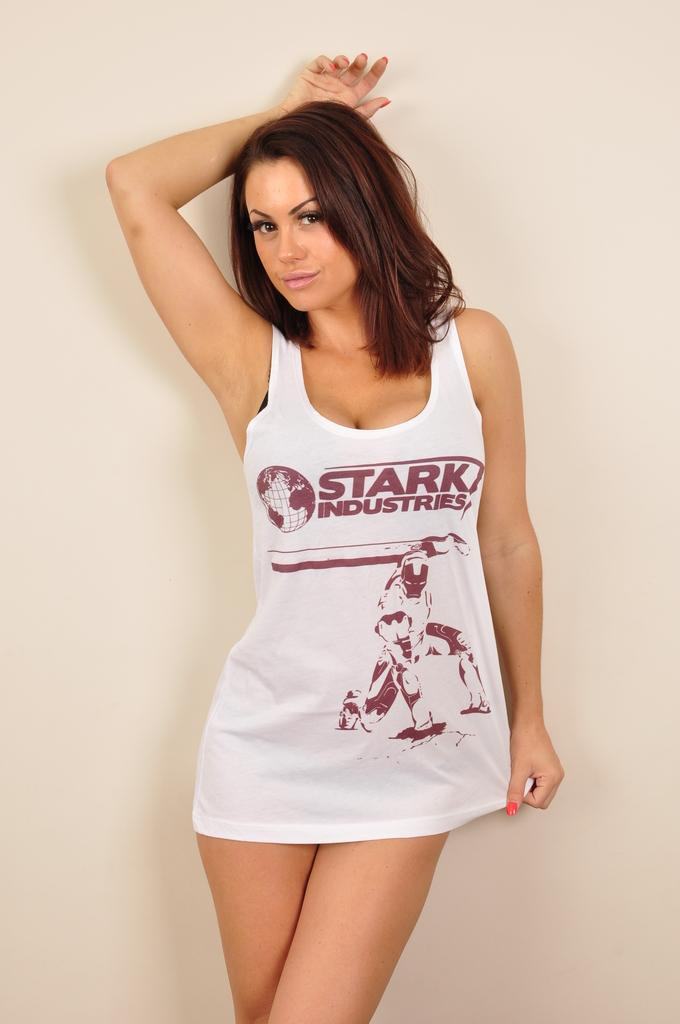<image>
Present a compact description of the photo's key features. A young woman is wearing only a tank top advertising Stark Industries. 